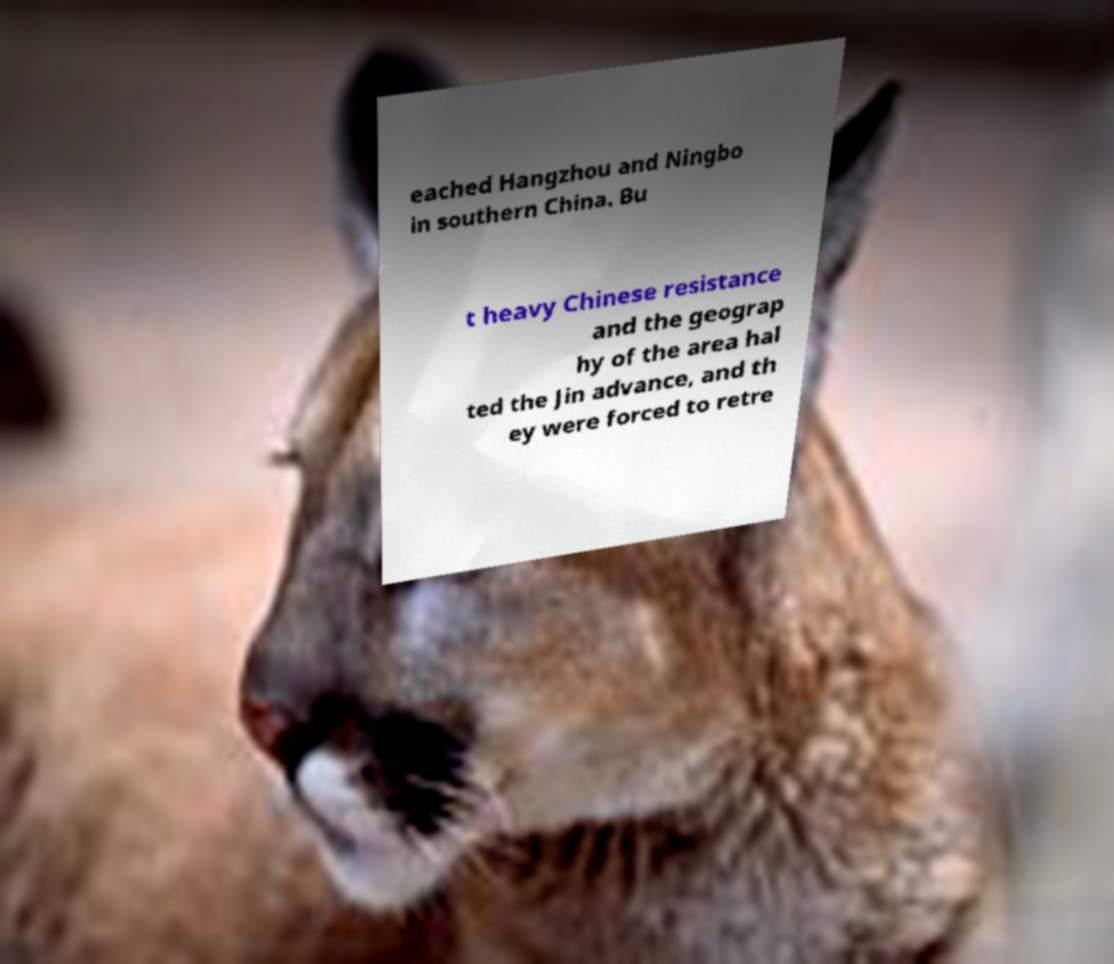I need the written content from this picture converted into text. Can you do that? eached Hangzhou and Ningbo in southern China. Bu t heavy Chinese resistance and the geograp hy of the area hal ted the Jin advance, and th ey were forced to retre 